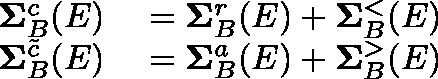Convert formula to latex. <formula><loc_0><loc_0><loc_500><loc_500>\begin{array} { r l } { \Sigma _ { B } ^ { c } ( E ) } & = \Sigma _ { B } ^ { r } ( E ) + \Sigma _ { B } ^ { < } ( E ) } \\ { \Sigma _ { B } ^ { \tilde { c } } ( E ) } & = \Sigma _ { B } ^ { a } ( E ) + \Sigma _ { B } ^ { > } ( E ) } \end{array}</formula> 